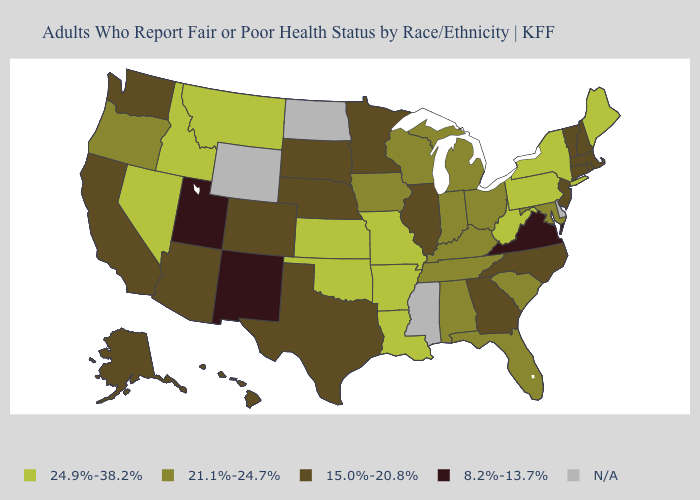Among the states that border Alabama , does Florida have the lowest value?
Concise answer only. No. Which states hav the highest value in the Northeast?
Short answer required. Maine, New York, Pennsylvania. Which states hav the highest value in the MidWest?
Short answer required. Kansas, Missouri. Which states have the lowest value in the South?
Keep it brief. Virginia. Name the states that have a value in the range 8.2%-13.7%?
Quick response, please. New Mexico, Utah, Virginia. Name the states that have a value in the range 24.9%-38.2%?
Keep it brief. Arkansas, Idaho, Kansas, Louisiana, Maine, Missouri, Montana, Nevada, New York, Oklahoma, Pennsylvania, West Virginia. Does Pennsylvania have the highest value in the USA?
Keep it brief. Yes. What is the lowest value in the West?
Be succinct. 8.2%-13.7%. Name the states that have a value in the range 24.9%-38.2%?
Quick response, please. Arkansas, Idaho, Kansas, Louisiana, Maine, Missouri, Montana, Nevada, New York, Oklahoma, Pennsylvania, West Virginia. Name the states that have a value in the range 24.9%-38.2%?
Short answer required. Arkansas, Idaho, Kansas, Louisiana, Maine, Missouri, Montana, Nevada, New York, Oklahoma, Pennsylvania, West Virginia. How many symbols are there in the legend?
Answer briefly. 5. Does the map have missing data?
Short answer required. Yes. Among the states that border Idaho , does Oregon have the lowest value?
Short answer required. No. Does Texas have the highest value in the USA?
Quick response, please. No. 